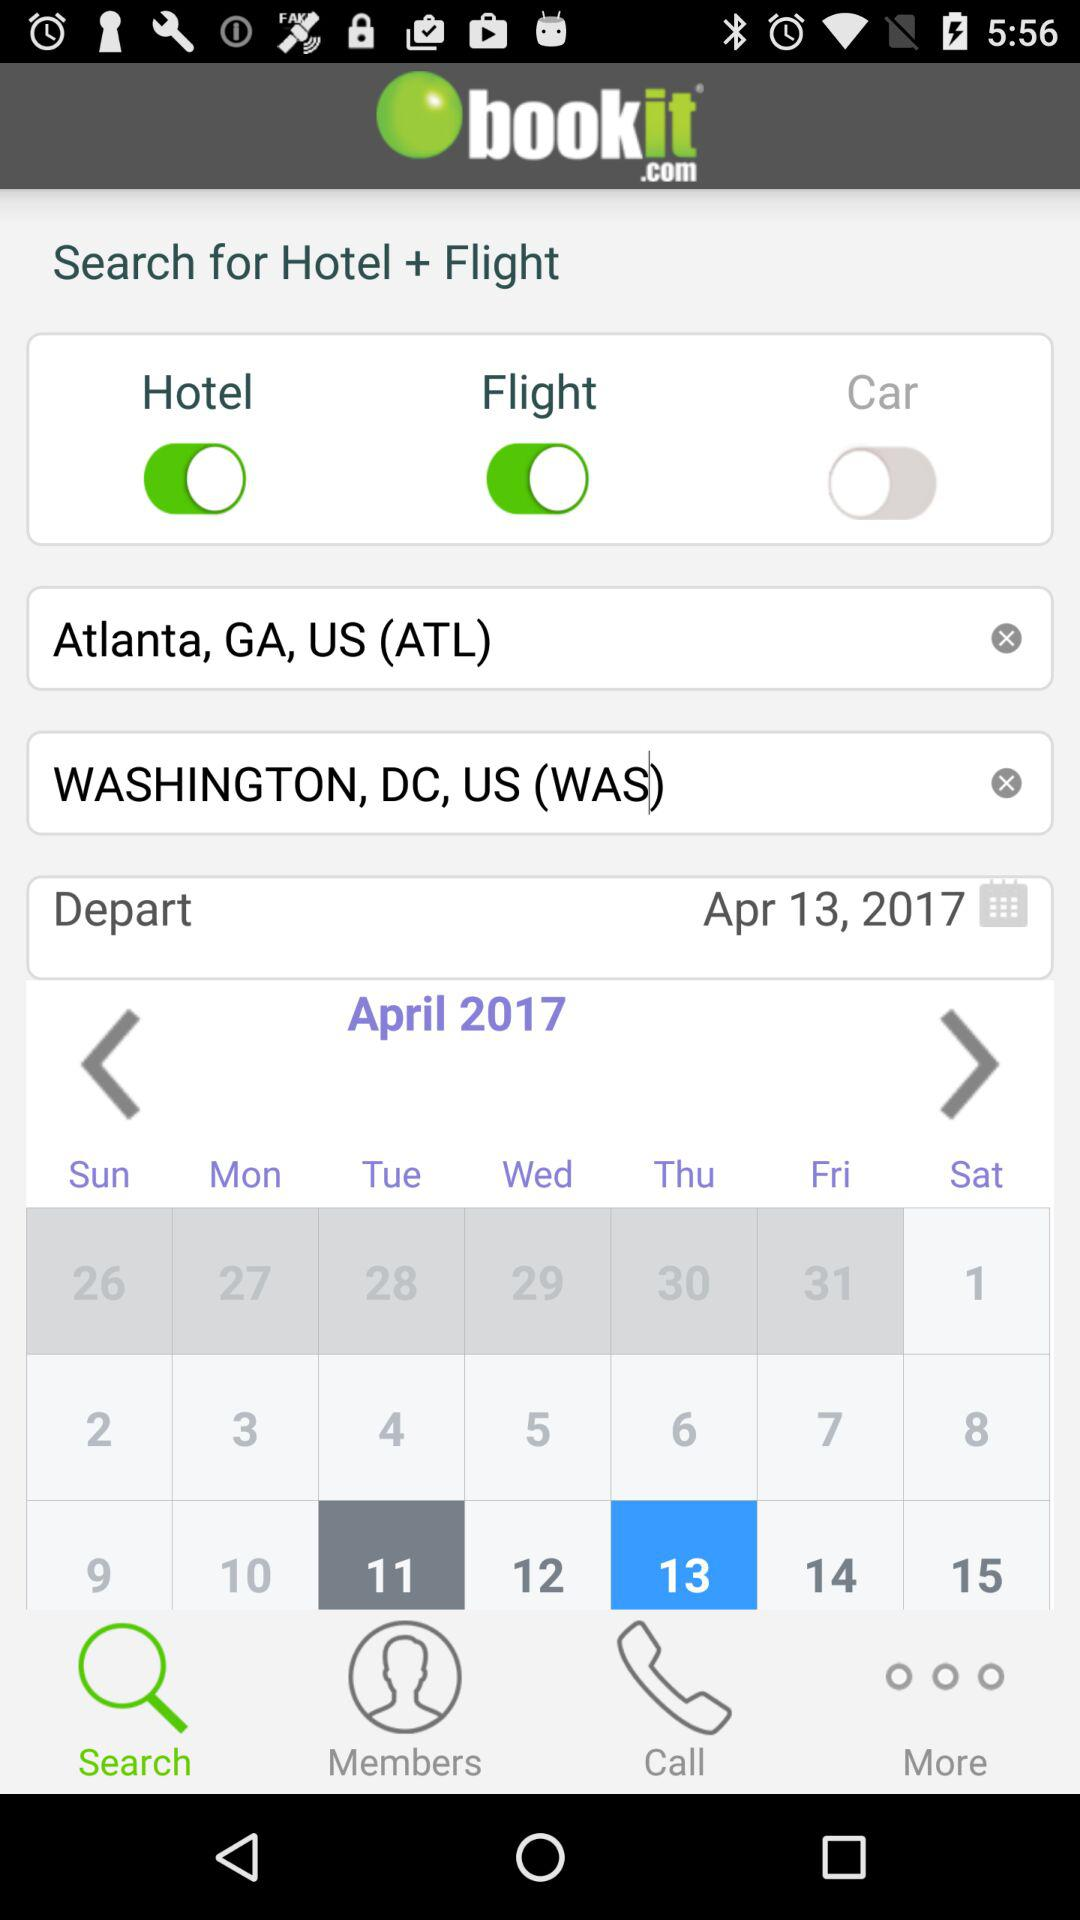What is the departure date? The departure date is April 13, 2017. 